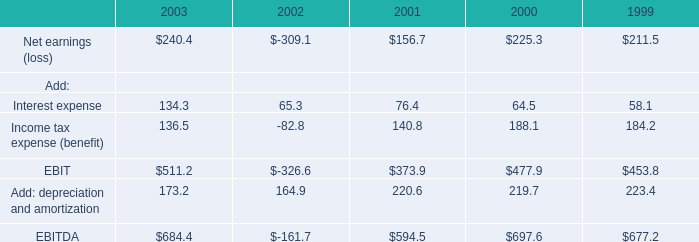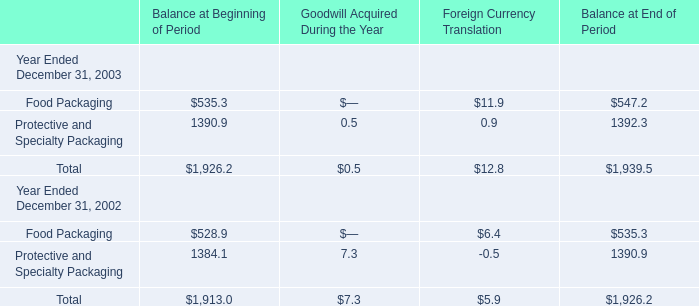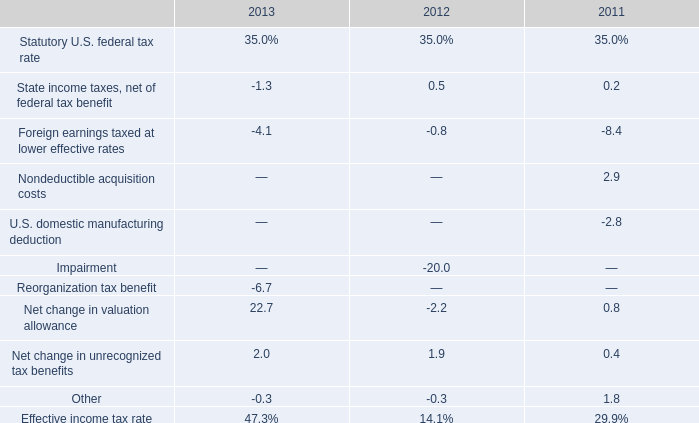What is the proportion of Food Packaging to the total in 2003 for Balance at Beginning of Period? 
Computations: (535.3 / (535.3 + 1390.9))
Answer: 0.2779. 